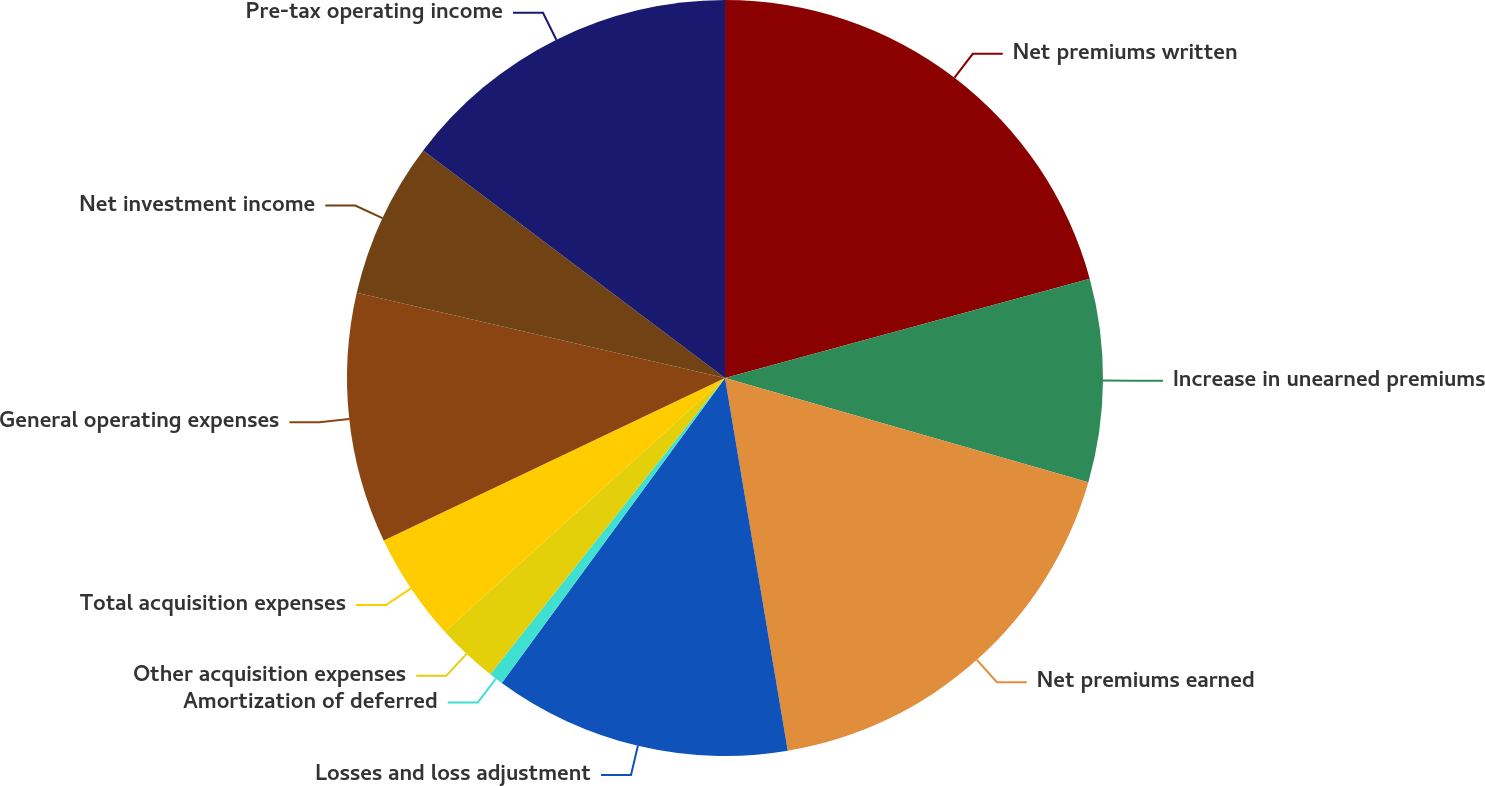Convert chart. <chart><loc_0><loc_0><loc_500><loc_500><pie_chart><fcel>Net premiums written<fcel>Increase in unearned premiums<fcel>Net premiums earned<fcel>Losses and loss adjustment<fcel>Amortization of deferred<fcel>Other acquisition expenses<fcel>Total acquisition expenses<fcel>General operating expenses<fcel>Net investment income<fcel>Pre-tax operating income<nl><fcel>20.77%<fcel>8.67%<fcel>17.9%<fcel>12.71%<fcel>0.61%<fcel>2.62%<fcel>4.64%<fcel>10.69%<fcel>6.66%<fcel>14.72%<nl></chart> 